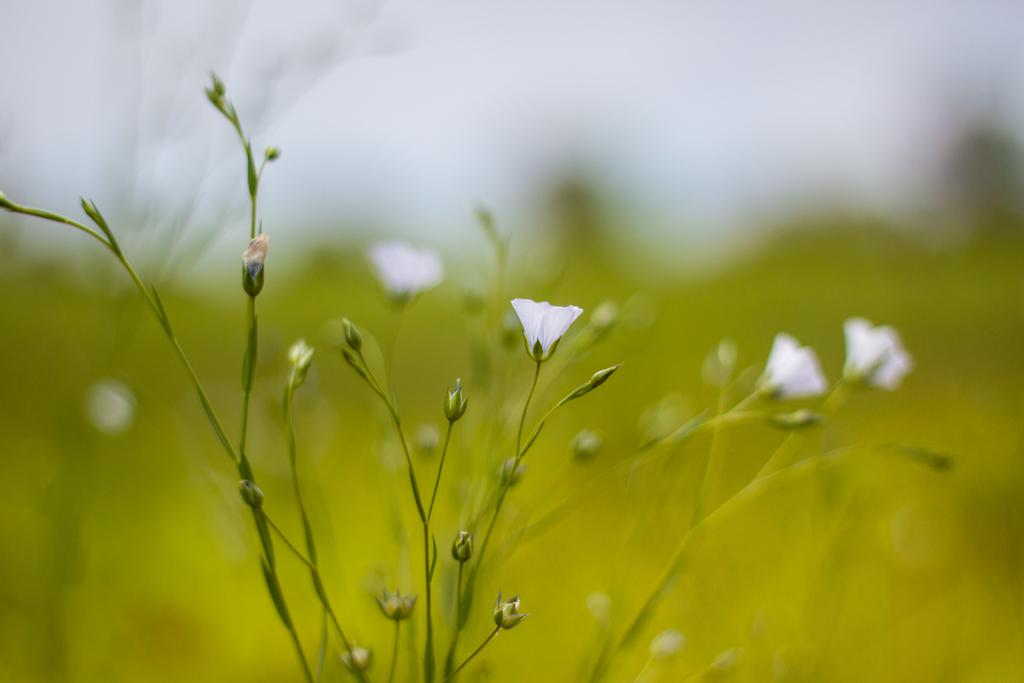What type of plants are in the front of the image? There are flower plants in the front of the image. Can you describe the background of the image? The background of the image is blurry. How many drawers are visible in the image? There are no drawers present in the image. What type of yoke can be seen in the image? There is no yoke present in the image. 